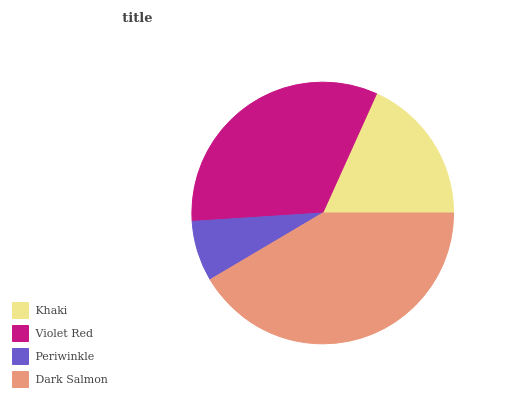Is Periwinkle the minimum?
Answer yes or no. Yes. Is Dark Salmon the maximum?
Answer yes or no. Yes. Is Violet Red the minimum?
Answer yes or no. No. Is Violet Red the maximum?
Answer yes or no. No. Is Violet Red greater than Khaki?
Answer yes or no. Yes. Is Khaki less than Violet Red?
Answer yes or no. Yes. Is Khaki greater than Violet Red?
Answer yes or no. No. Is Violet Red less than Khaki?
Answer yes or no. No. Is Violet Red the high median?
Answer yes or no. Yes. Is Khaki the low median?
Answer yes or no. Yes. Is Dark Salmon the high median?
Answer yes or no. No. Is Dark Salmon the low median?
Answer yes or no. No. 